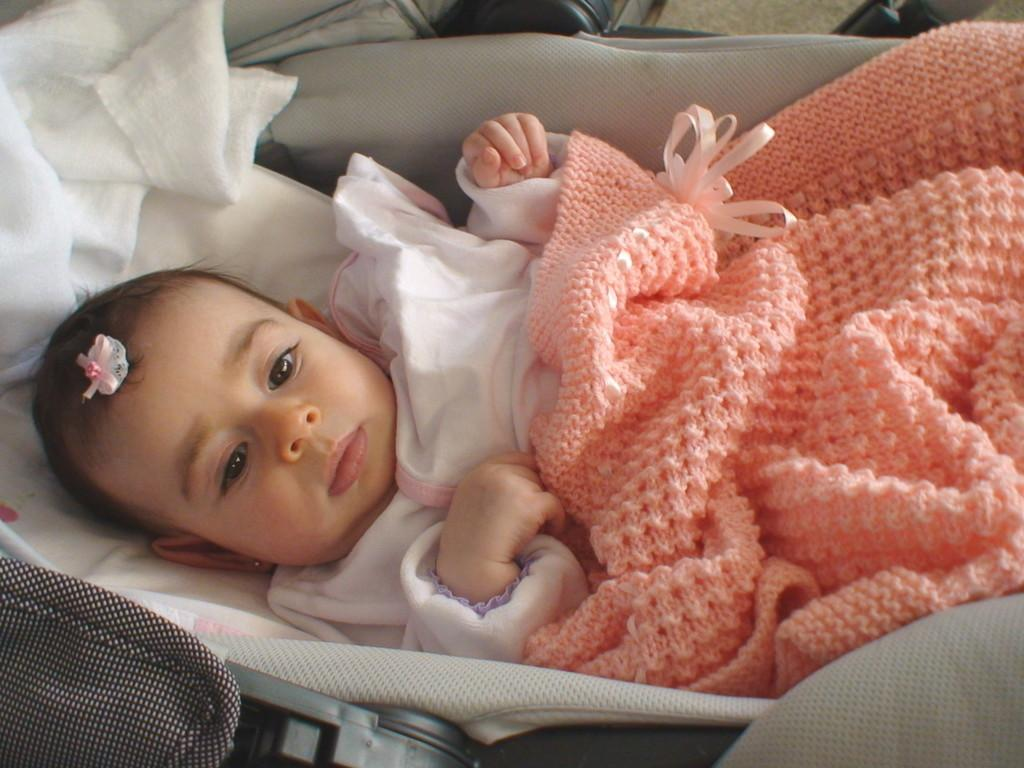What is the main subject of the image? There is a baby in the image. What is the baby's position in the image? The baby is laying on a trolley. What is the baby wearing in the image? The baby is wearing a white and peach color dress. What can be seen in the background of the image? There is a white color cloth in the background of the image. What type of plantation can be seen in the background of the image? There is no plantation present in the image; it only features a baby laying on a trolley and a white cloth in the background. How many seeds are visible in the image? There are no seeds visible in the image. 